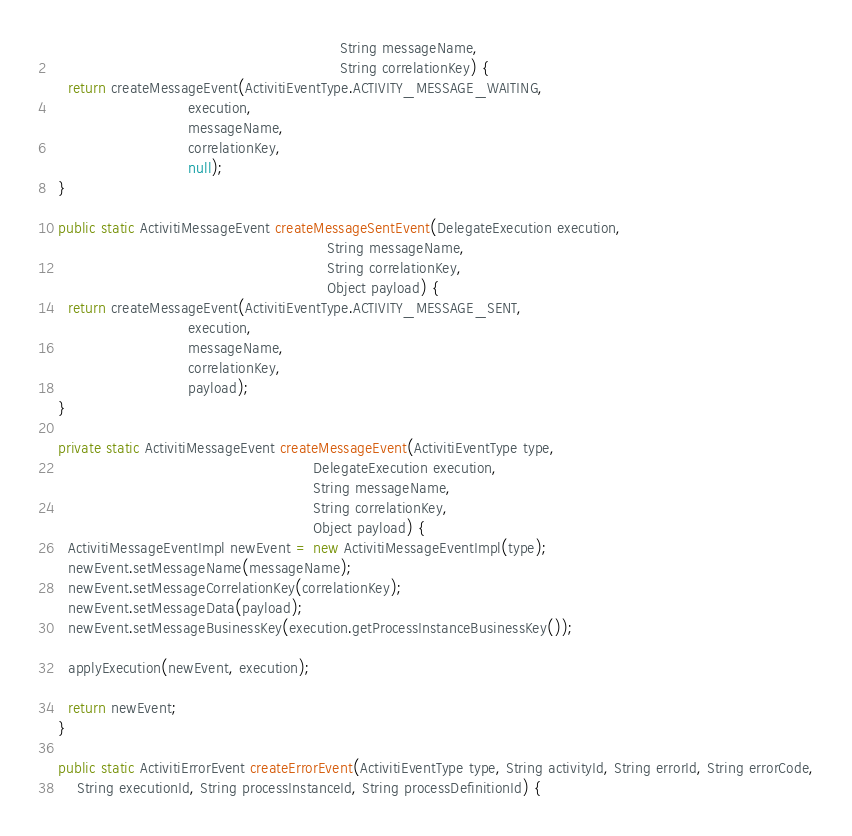<code> <loc_0><loc_0><loc_500><loc_500><_Java_>                                                               String messageName,
                                                               String correlationKey) {
    return createMessageEvent(ActivitiEventType.ACTIVITY_MESSAGE_WAITING,
                              execution,
                              messageName,
                              correlationKey,
                              null);
  }

  public static ActivitiMessageEvent createMessageSentEvent(DelegateExecution execution,
                                                            String messageName,
                                                            String correlationKey,
                                                            Object payload) {
    return createMessageEvent(ActivitiEventType.ACTIVITY_MESSAGE_SENT,
                              execution,
                              messageName,
                              correlationKey,
                              payload);
  }
  
  private static ActivitiMessageEvent createMessageEvent(ActivitiEventType type, 
                                                         DelegateExecution execution,
                                                         String messageName, 
                                                         String correlationKey, 
                                                         Object payload) {
    ActivitiMessageEventImpl newEvent = new ActivitiMessageEventImpl(type);
    newEvent.setMessageName(messageName);
    newEvent.setMessageCorrelationKey(correlationKey);
    newEvent.setMessageData(payload);  
    newEvent.setMessageBusinessKey(execution.getProcessInstanceBusinessKey());

    applyExecution(newEvent, execution);
    
    return newEvent;
  } 

  public static ActivitiErrorEvent createErrorEvent(ActivitiEventType type, String activityId, String errorId, String errorCode,
      String executionId, String processInstanceId, String processDefinitionId) {</code> 